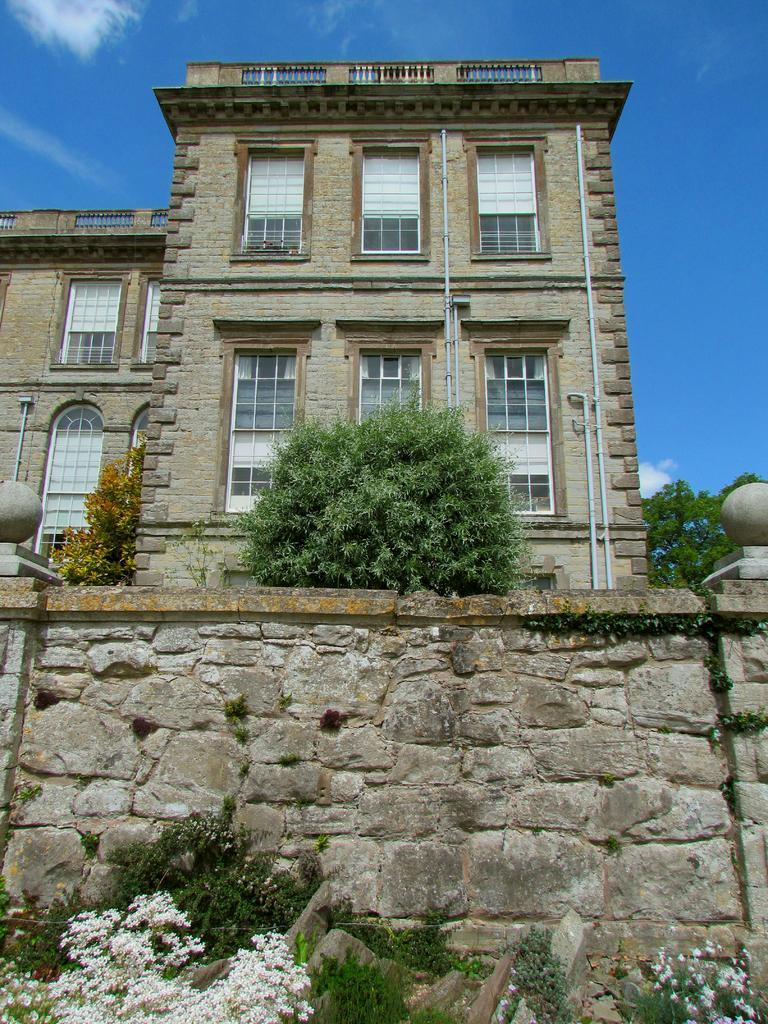What type of structure is present in the image? There is a building in the image. What is located in front of the building? There are trees and plants in front of the building. What can be seen in the background of the image? The sky is visible in the background of the image. How many flags are visible in the image? There are no flags present in the image. What type of card is being used in the image? There is no card present in the image. 